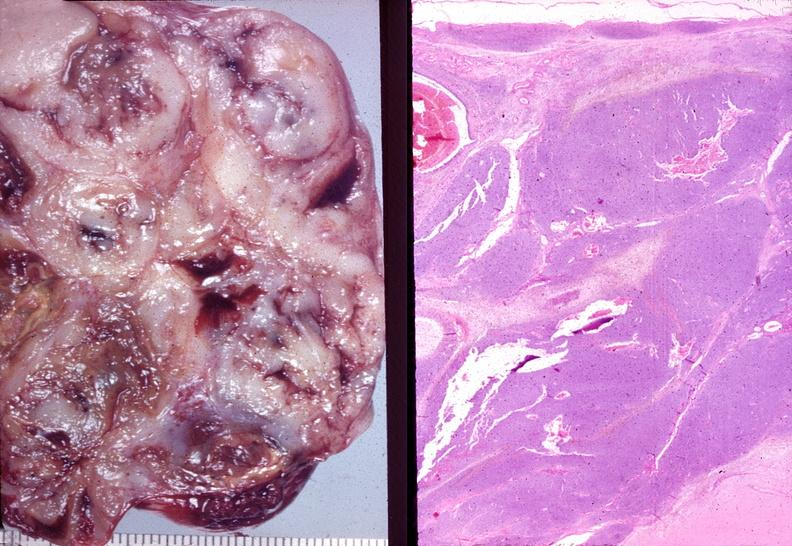s yo present?
Answer the question using a single word or phrase. No 